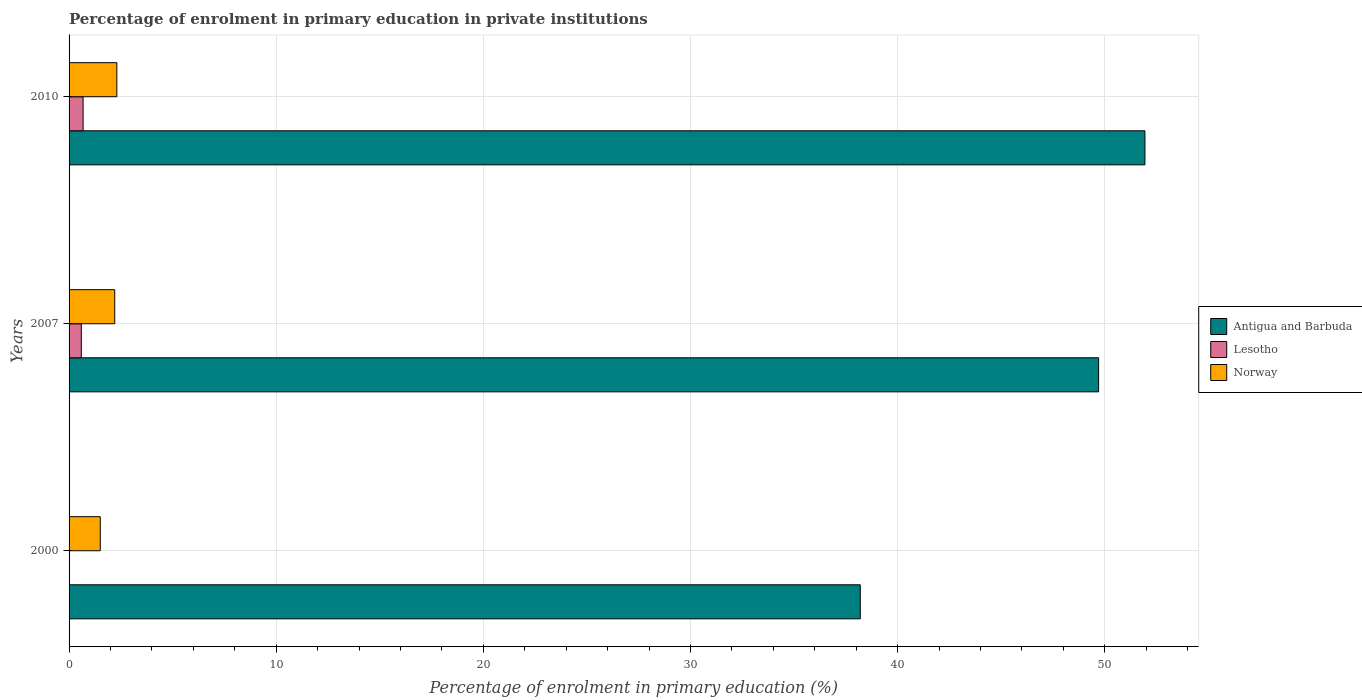How many groups of bars are there?
Provide a short and direct response. 3. Are the number of bars per tick equal to the number of legend labels?
Your answer should be very brief. Yes. How many bars are there on the 1st tick from the top?
Provide a short and direct response. 3. How many bars are there on the 3rd tick from the bottom?
Give a very brief answer. 3. In how many cases, is the number of bars for a given year not equal to the number of legend labels?
Offer a very short reply. 0. What is the percentage of enrolment in primary education in Norway in 2007?
Keep it short and to the point. 2.2. Across all years, what is the maximum percentage of enrolment in primary education in Norway?
Give a very brief answer. 2.31. Across all years, what is the minimum percentage of enrolment in primary education in Lesotho?
Make the answer very short. 0.01. In which year was the percentage of enrolment in primary education in Lesotho maximum?
Keep it short and to the point. 2010. What is the total percentage of enrolment in primary education in Antigua and Barbuda in the graph?
Provide a short and direct response. 139.83. What is the difference between the percentage of enrolment in primary education in Lesotho in 2000 and that in 2010?
Your answer should be very brief. -0.66. What is the difference between the percentage of enrolment in primary education in Antigua and Barbuda in 2010 and the percentage of enrolment in primary education in Norway in 2007?
Provide a succinct answer. 49.73. What is the average percentage of enrolment in primary education in Antigua and Barbuda per year?
Offer a very short reply. 46.61. In the year 2010, what is the difference between the percentage of enrolment in primary education in Antigua and Barbuda and percentage of enrolment in primary education in Lesotho?
Keep it short and to the point. 51.26. In how many years, is the percentage of enrolment in primary education in Antigua and Barbuda greater than 16 %?
Provide a succinct answer. 3. What is the ratio of the percentage of enrolment in primary education in Norway in 2007 to that in 2010?
Offer a very short reply. 0.96. Is the percentage of enrolment in primary education in Norway in 2000 less than that in 2010?
Your answer should be very brief. Yes. What is the difference between the highest and the second highest percentage of enrolment in primary education in Antigua and Barbuda?
Your response must be concise. 2.24. What is the difference between the highest and the lowest percentage of enrolment in primary education in Antigua and Barbuda?
Your answer should be very brief. 13.74. In how many years, is the percentage of enrolment in primary education in Norway greater than the average percentage of enrolment in primary education in Norway taken over all years?
Your answer should be compact. 2. Is the sum of the percentage of enrolment in primary education in Lesotho in 2000 and 2010 greater than the maximum percentage of enrolment in primary education in Antigua and Barbuda across all years?
Provide a succinct answer. No. What does the 2nd bar from the top in 2000 represents?
Offer a terse response. Lesotho. What does the 1st bar from the bottom in 2000 represents?
Ensure brevity in your answer.  Antigua and Barbuda. Is it the case that in every year, the sum of the percentage of enrolment in primary education in Norway and percentage of enrolment in primary education in Lesotho is greater than the percentage of enrolment in primary education in Antigua and Barbuda?
Provide a short and direct response. No. What is the difference between two consecutive major ticks on the X-axis?
Ensure brevity in your answer.  10. Are the values on the major ticks of X-axis written in scientific E-notation?
Provide a short and direct response. No. Does the graph contain grids?
Provide a succinct answer. Yes. Where does the legend appear in the graph?
Keep it short and to the point. Center right. What is the title of the graph?
Provide a short and direct response. Percentage of enrolment in primary education in private institutions. What is the label or title of the X-axis?
Make the answer very short. Percentage of enrolment in primary education (%). What is the label or title of the Y-axis?
Your answer should be compact. Years. What is the Percentage of enrolment in primary education (%) of Antigua and Barbuda in 2000?
Provide a short and direct response. 38.2. What is the Percentage of enrolment in primary education (%) in Lesotho in 2000?
Offer a very short reply. 0.01. What is the Percentage of enrolment in primary education (%) of Norway in 2000?
Ensure brevity in your answer.  1.51. What is the Percentage of enrolment in primary education (%) in Antigua and Barbuda in 2007?
Your answer should be very brief. 49.7. What is the Percentage of enrolment in primary education (%) in Lesotho in 2007?
Make the answer very short. 0.59. What is the Percentage of enrolment in primary education (%) in Norway in 2007?
Keep it short and to the point. 2.2. What is the Percentage of enrolment in primary education (%) in Antigua and Barbuda in 2010?
Your answer should be very brief. 51.94. What is the Percentage of enrolment in primary education (%) of Lesotho in 2010?
Give a very brief answer. 0.68. What is the Percentage of enrolment in primary education (%) in Norway in 2010?
Offer a very short reply. 2.31. Across all years, what is the maximum Percentage of enrolment in primary education (%) of Antigua and Barbuda?
Provide a short and direct response. 51.94. Across all years, what is the maximum Percentage of enrolment in primary education (%) of Lesotho?
Your response must be concise. 0.68. Across all years, what is the maximum Percentage of enrolment in primary education (%) of Norway?
Keep it short and to the point. 2.31. Across all years, what is the minimum Percentage of enrolment in primary education (%) in Antigua and Barbuda?
Your answer should be very brief. 38.2. Across all years, what is the minimum Percentage of enrolment in primary education (%) in Lesotho?
Provide a succinct answer. 0.01. Across all years, what is the minimum Percentage of enrolment in primary education (%) of Norway?
Keep it short and to the point. 1.51. What is the total Percentage of enrolment in primary education (%) of Antigua and Barbuda in the graph?
Make the answer very short. 139.83. What is the total Percentage of enrolment in primary education (%) of Lesotho in the graph?
Provide a short and direct response. 1.28. What is the total Percentage of enrolment in primary education (%) in Norway in the graph?
Give a very brief answer. 6.02. What is the difference between the Percentage of enrolment in primary education (%) of Antigua and Barbuda in 2000 and that in 2007?
Your response must be concise. -11.51. What is the difference between the Percentage of enrolment in primary education (%) of Lesotho in 2000 and that in 2007?
Your response must be concise. -0.58. What is the difference between the Percentage of enrolment in primary education (%) in Norway in 2000 and that in 2007?
Provide a succinct answer. -0.7. What is the difference between the Percentage of enrolment in primary education (%) in Antigua and Barbuda in 2000 and that in 2010?
Your answer should be compact. -13.74. What is the difference between the Percentage of enrolment in primary education (%) in Lesotho in 2000 and that in 2010?
Keep it short and to the point. -0.66. What is the difference between the Percentage of enrolment in primary education (%) in Norway in 2000 and that in 2010?
Your answer should be very brief. -0.8. What is the difference between the Percentage of enrolment in primary education (%) in Antigua and Barbuda in 2007 and that in 2010?
Your answer should be compact. -2.24. What is the difference between the Percentage of enrolment in primary education (%) of Lesotho in 2007 and that in 2010?
Your response must be concise. -0.09. What is the difference between the Percentage of enrolment in primary education (%) in Norway in 2007 and that in 2010?
Provide a short and direct response. -0.1. What is the difference between the Percentage of enrolment in primary education (%) in Antigua and Barbuda in 2000 and the Percentage of enrolment in primary education (%) in Lesotho in 2007?
Keep it short and to the point. 37.61. What is the difference between the Percentage of enrolment in primary education (%) of Antigua and Barbuda in 2000 and the Percentage of enrolment in primary education (%) of Norway in 2007?
Make the answer very short. 35.99. What is the difference between the Percentage of enrolment in primary education (%) in Lesotho in 2000 and the Percentage of enrolment in primary education (%) in Norway in 2007?
Make the answer very short. -2.19. What is the difference between the Percentage of enrolment in primary education (%) in Antigua and Barbuda in 2000 and the Percentage of enrolment in primary education (%) in Lesotho in 2010?
Keep it short and to the point. 37.52. What is the difference between the Percentage of enrolment in primary education (%) in Antigua and Barbuda in 2000 and the Percentage of enrolment in primary education (%) in Norway in 2010?
Offer a terse response. 35.89. What is the difference between the Percentage of enrolment in primary education (%) of Lesotho in 2000 and the Percentage of enrolment in primary education (%) of Norway in 2010?
Ensure brevity in your answer.  -2.29. What is the difference between the Percentage of enrolment in primary education (%) of Antigua and Barbuda in 2007 and the Percentage of enrolment in primary education (%) of Lesotho in 2010?
Make the answer very short. 49.03. What is the difference between the Percentage of enrolment in primary education (%) of Antigua and Barbuda in 2007 and the Percentage of enrolment in primary education (%) of Norway in 2010?
Ensure brevity in your answer.  47.4. What is the difference between the Percentage of enrolment in primary education (%) of Lesotho in 2007 and the Percentage of enrolment in primary education (%) of Norway in 2010?
Give a very brief answer. -1.72. What is the average Percentage of enrolment in primary education (%) of Antigua and Barbuda per year?
Your response must be concise. 46.61. What is the average Percentage of enrolment in primary education (%) in Lesotho per year?
Make the answer very short. 0.43. What is the average Percentage of enrolment in primary education (%) in Norway per year?
Your answer should be compact. 2.01. In the year 2000, what is the difference between the Percentage of enrolment in primary education (%) of Antigua and Barbuda and Percentage of enrolment in primary education (%) of Lesotho?
Make the answer very short. 38.18. In the year 2000, what is the difference between the Percentage of enrolment in primary education (%) in Antigua and Barbuda and Percentage of enrolment in primary education (%) in Norway?
Give a very brief answer. 36.69. In the year 2000, what is the difference between the Percentage of enrolment in primary education (%) in Lesotho and Percentage of enrolment in primary education (%) in Norway?
Ensure brevity in your answer.  -1.49. In the year 2007, what is the difference between the Percentage of enrolment in primary education (%) of Antigua and Barbuda and Percentage of enrolment in primary education (%) of Lesotho?
Provide a succinct answer. 49.11. In the year 2007, what is the difference between the Percentage of enrolment in primary education (%) in Antigua and Barbuda and Percentage of enrolment in primary education (%) in Norway?
Offer a terse response. 47.5. In the year 2007, what is the difference between the Percentage of enrolment in primary education (%) of Lesotho and Percentage of enrolment in primary education (%) of Norway?
Make the answer very short. -1.61. In the year 2010, what is the difference between the Percentage of enrolment in primary education (%) of Antigua and Barbuda and Percentage of enrolment in primary education (%) of Lesotho?
Give a very brief answer. 51.26. In the year 2010, what is the difference between the Percentage of enrolment in primary education (%) of Antigua and Barbuda and Percentage of enrolment in primary education (%) of Norway?
Provide a short and direct response. 49.63. In the year 2010, what is the difference between the Percentage of enrolment in primary education (%) in Lesotho and Percentage of enrolment in primary education (%) in Norway?
Ensure brevity in your answer.  -1.63. What is the ratio of the Percentage of enrolment in primary education (%) of Antigua and Barbuda in 2000 to that in 2007?
Your answer should be compact. 0.77. What is the ratio of the Percentage of enrolment in primary education (%) in Lesotho in 2000 to that in 2007?
Your answer should be compact. 0.02. What is the ratio of the Percentage of enrolment in primary education (%) of Norway in 2000 to that in 2007?
Your answer should be very brief. 0.68. What is the ratio of the Percentage of enrolment in primary education (%) in Antigua and Barbuda in 2000 to that in 2010?
Give a very brief answer. 0.74. What is the ratio of the Percentage of enrolment in primary education (%) in Lesotho in 2000 to that in 2010?
Ensure brevity in your answer.  0.02. What is the ratio of the Percentage of enrolment in primary education (%) of Norway in 2000 to that in 2010?
Your answer should be compact. 0.65. What is the ratio of the Percentage of enrolment in primary education (%) in Lesotho in 2007 to that in 2010?
Provide a short and direct response. 0.87. What is the ratio of the Percentage of enrolment in primary education (%) of Norway in 2007 to that in 2010?
Provide a short and direct response. 0.96. What is the difference between the highest and the second highest Percentage of enrolment in primary education (%) of Antigua and Barbuda?
Your answer should be compact. 2.24. What is the difference between the highest and the second highest Percentage of enrolment in primary education (%) in Lesotho?
Your response must be concise. 0.09. What is the difference between the highest and the second highest Percentage of enrolment in primary education (%) of Norway?
Provide a short and direct response. 0.1. What is the difference between the highest and the lowest Percentage of enrolment in primary education (%) of Antigua and Barbuda?
Your answer should be very brief. 13.74. What is the difference between the highest and the lowest Percentage of enrolment in primary education (%) in Lesotho?
Ensure brevity in your answer.  0.66. What is the difference between the highest and the lowest Percentage of enrolment in primary education (%) in Norway?
Your answer should be very brief. 0.8. 